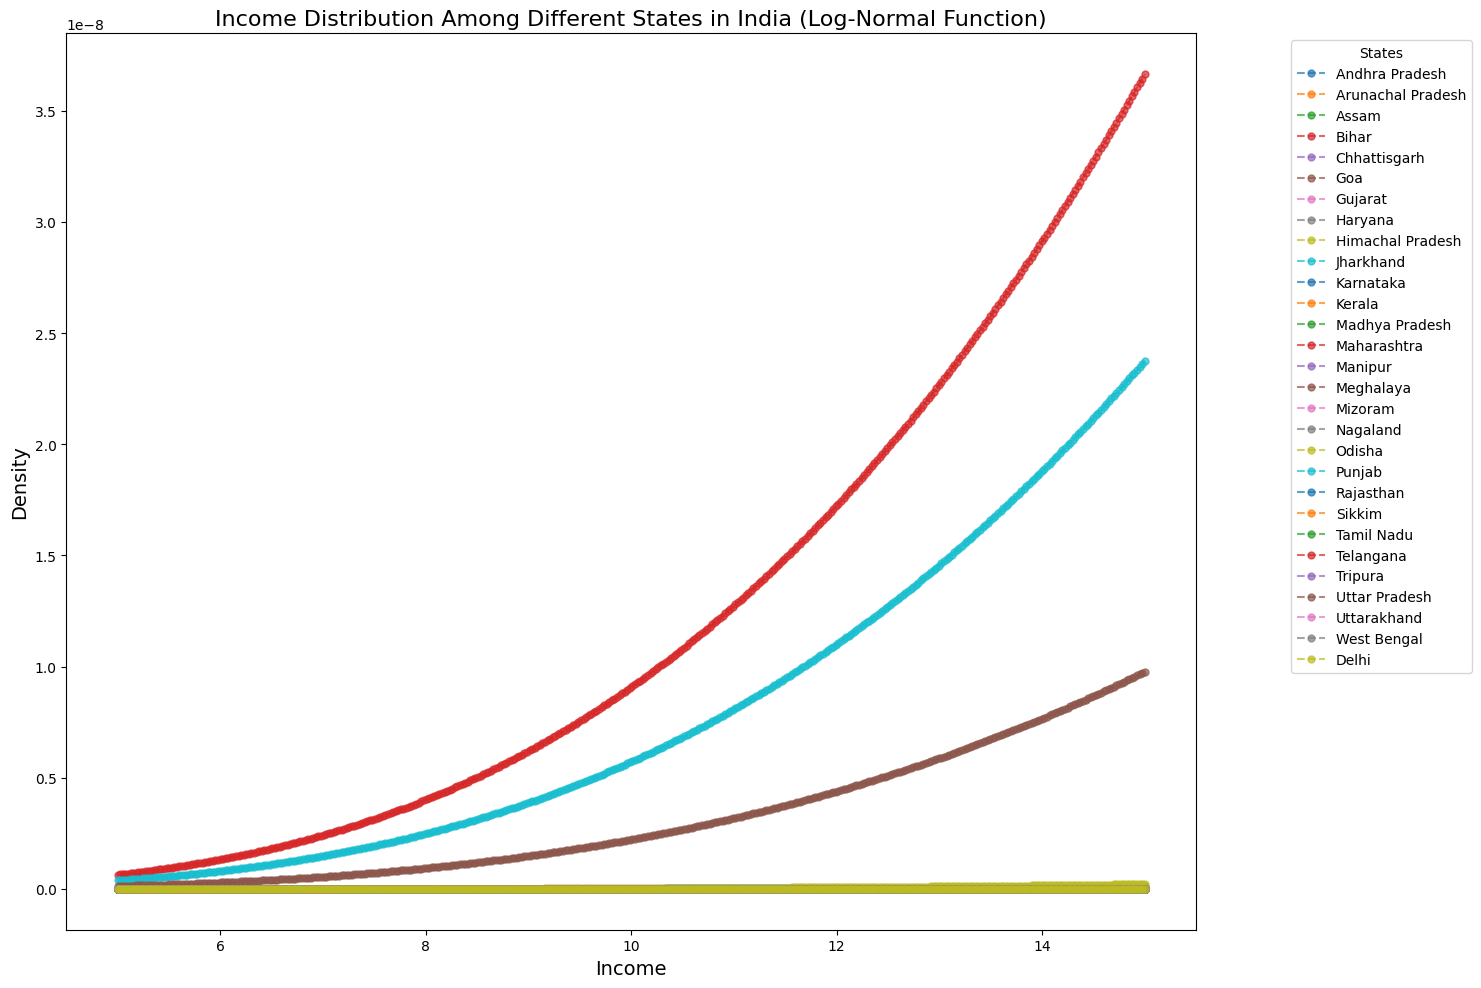Which state has the highest peak in the density function? By observing the density curves, the state with the highest peak is the one where the curve reaches its maximum height. This indicates the state with the highest concentration of income around its mean.
Answer: Goa Which two states have the most similar income distribution densities? Look for two states whose density curves have similar shapes and peak at similar income values, indicating similar mean and standard deviation.
Answer: Assam and Himachal Pradesh What is the main visual difference in the income distribution between Goa and Bihar? Goa's density curve is narrow and peaks at a higher income, meaning it has a higher mean log-income and smaller standard deviation. Bihar's curve is wider and peaks at a lower income, indicating a lower mean log-income and higher standard deviation.
Answer: Goa has a higher and narrower peak, Bihar has a lower and wider peak Which state has the widest range of income distribution? The widest range of income distribution corresponds to the state with the flattest and broadest curve, reflecting a higher standard deviation.
Answer: Bihar How does Delhi's income distribution density compare to its neighboring states like Haryana? Compare the peak and spread of the density curves for Delhi and Haryana. Delhi has a higher and narrower peak compared to Haryana, indicating a higher mean log-income and smaller standard deviation.
Answer: Delhi has a higher and narrower peak than Haryana If you were to average the mean log-income of Andhra Pradesh and Karnataka, what would the result be? Calculate the mean of Andhra Pradesh (10.5) and Karnataka (10.4) by adding them and dividing by two. The average is (10.5 + 10.4) / 2 = 10.45.
Answer: 10.45 Which state has a mean log-income closest to the overall average of all states? To find this, first calculate the average of all mean log-incomes, then locate the state whose mean log-income is nearest to this average. The overall mean is approximately (sum of all mean log-incomes) / 28 ≈ 10.1. The state closest to this value is Assam or Uttarakhand.
Answer: Assam or Uttarakhand How does the income distribution of Maharashtra compare to Tamil Nadu? Look at the height and spread of the density curves for Maharashtra and Tamil Nadu. Both states have slightly different peaks and similar spreads, indicating slight differences in mean log-income and standard deviation.
Answer: Both have similar spreads, slight differences in peaks What is the primary difference in income distribution between Kerala and Jharkhand? Kerala's density curve is high and narrow, indicating a higher mean log-income and smaller standard deviation. Jharkhand's curve is lower and wider, reflecting a lower mean log-income and higher standard deviation.
Answer: Kerala’s curve is higher and narrower, Jharkhand’s is lower and wider What trend do you notice when comparing the income distributions of Northern states (e.g., Punjab, Haryana) to Southern states (e.g., Kerala, Tamil Nadu)? Northern states like Punjab and Haryana have relatively high and narrow peaks, indicating higher mean incomes and less variability. Southern states like Kerala and Tamil Nadu also have high peaks but not as narrow, reflecting high mean incomes with moderate variability.
Answer: Northern states have slightly higher/narrow peaks, Southern states have high but less narrow peaks 